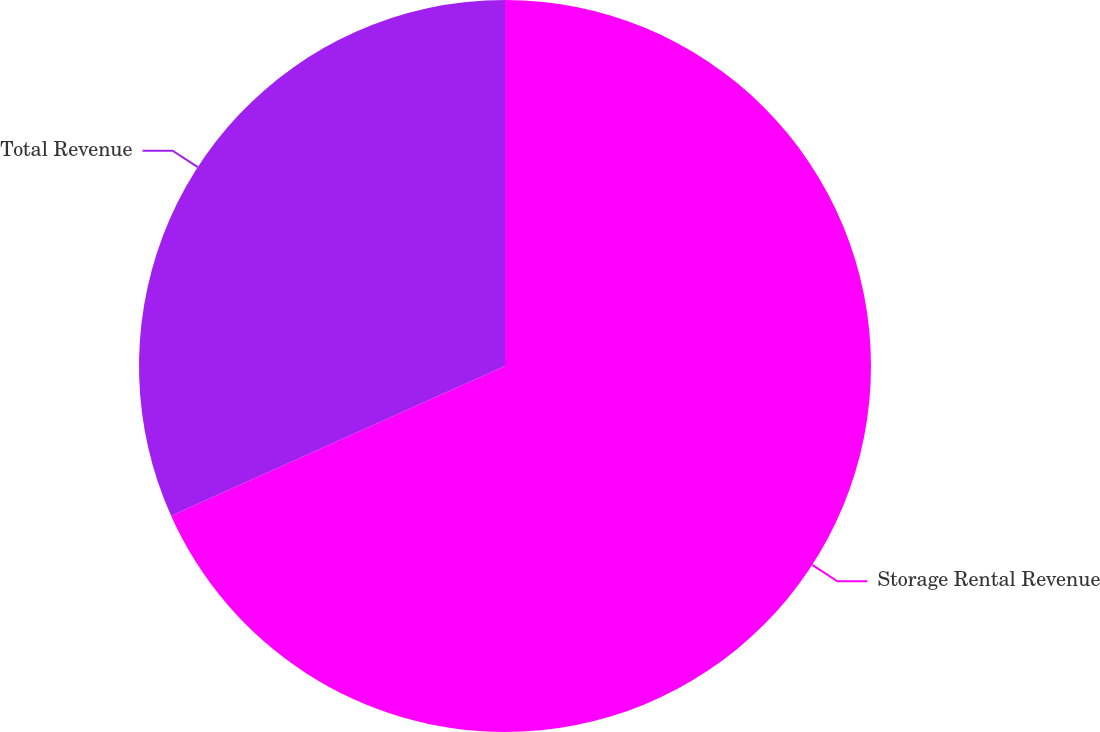Convert chart. <chart><loc_0><loc_0><loc_500><loc_500><pie_chart><fcel>Storage Rental Revenue<fcel>Total Revenue<nl><fcel>68.29%<fcel>31.71%<nl></chart> 